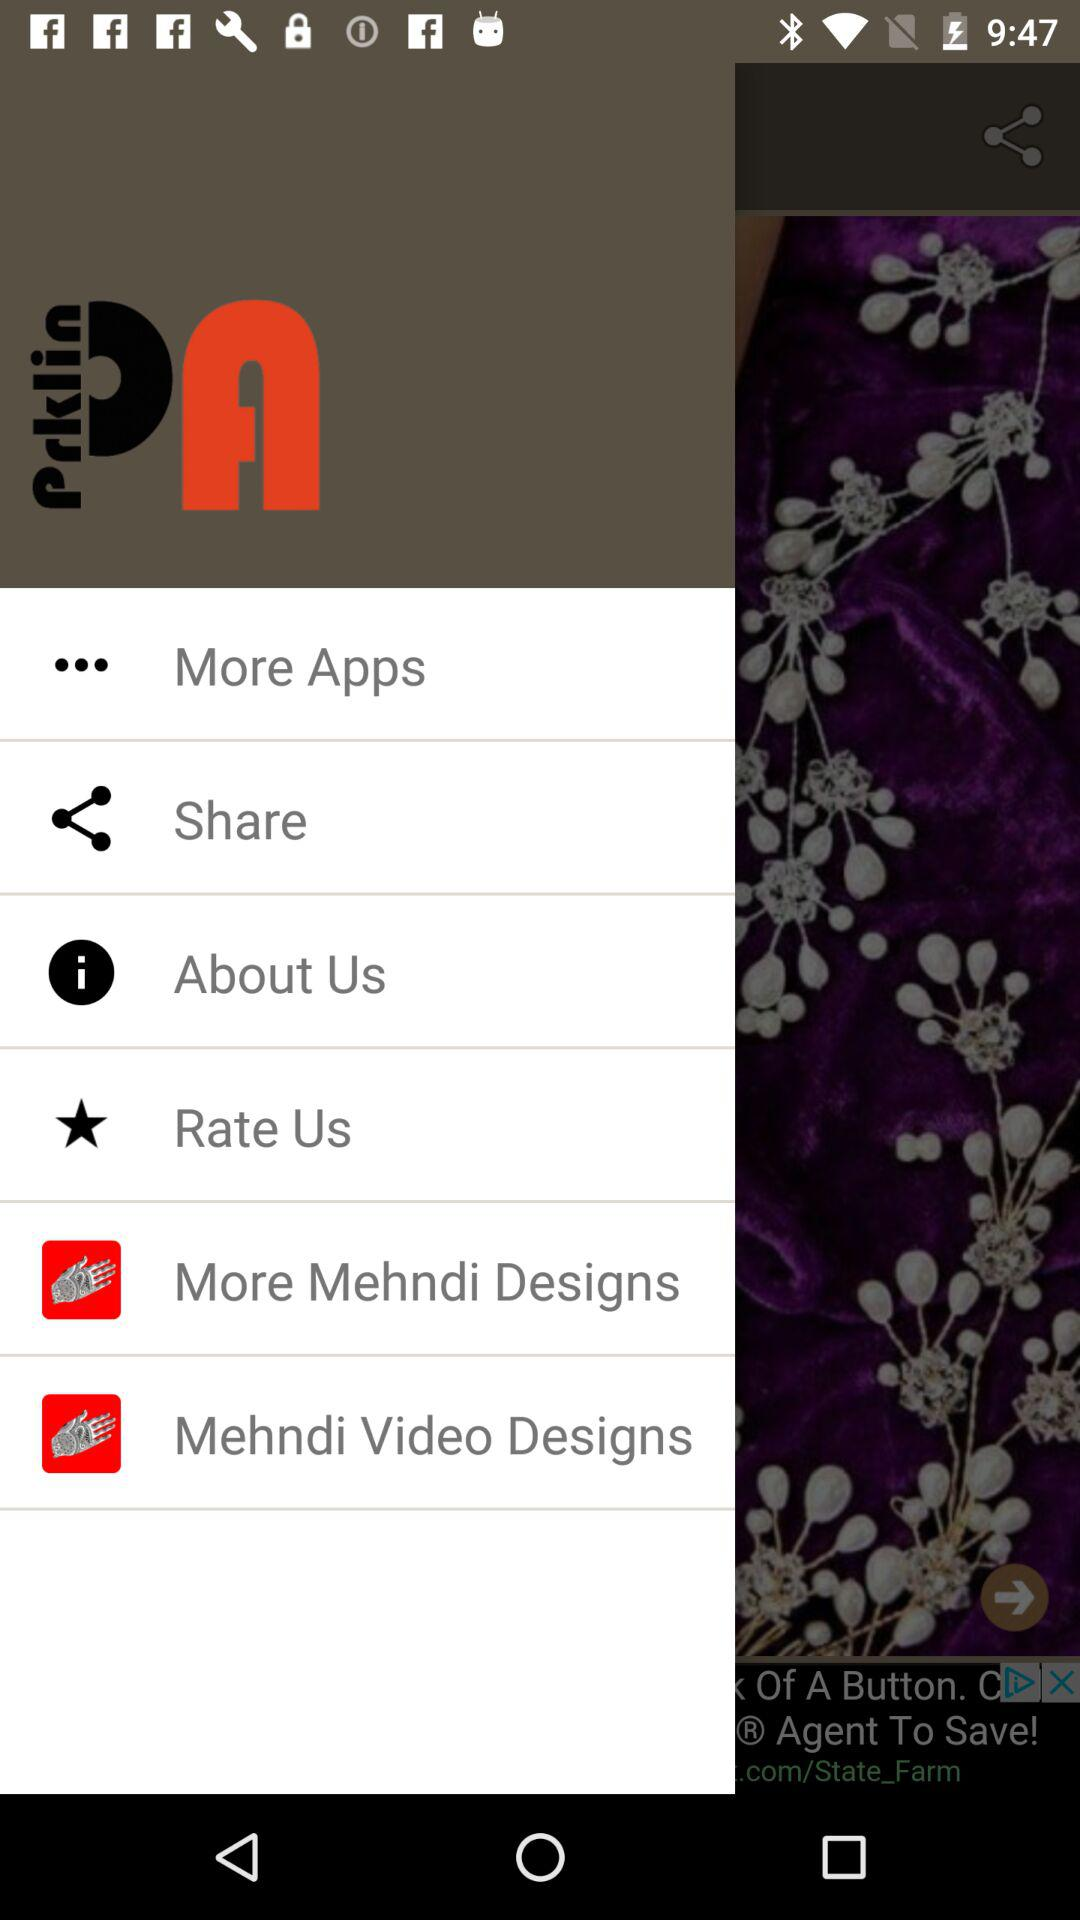What is the name of the application? The name of the application is "Mehndi Designs". 